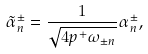Convert formula to latex. <formula><loc_0><loc_0><loc_500><loc_500>\tilde { \alpha } _ { n } ^ { \pm } = \frac { 1 } { \sqrt { 4 p ^ { + } \omega _ { \pm n } } } \alpha _ { n } ^ { \pm } ,</formula> 